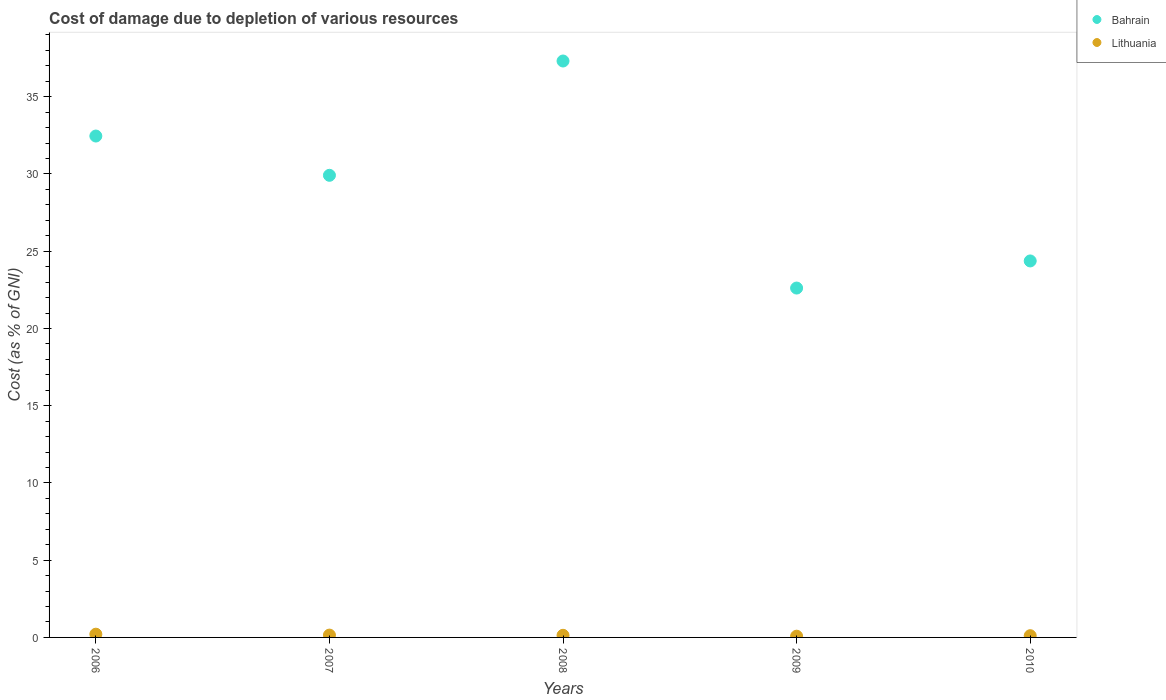How many different coloured dotlines are there?
Provide a short and direct response. 2. Is the number of dotlines equal to the number of legend labels?
Keep it short and to the point. Yes. What is the cost of damage caused due to the depletion of various resources in Lithuania in 2009?
Give a very brief answer. 0.08. Across all years, what is the maximum cost of damage caused due to the depletion of various resources in Bahrain?
Offer a very short reply. 37.31. Across all years, what is the minimum cost of damage caused due to the depletion of various resources in Bahrain?
Offer a very short reply. 22.62. What is the total cost of damage caused due to the depletion of various resources in Lithuania in the graph?
Keep it short and to the point. 0.69. What is the difference between the cost of damage caused due to the depletion of various resources in Bahrain in 2006 and that in 2007?
Make the answer very short. 2.54. What is the difference between the cost of damage caused due to the depletion of various resources in Bahrain in 2008 and the cost of damage caused due to the depletion of various resources in Lithuania in 2009?
Ensure brevity in your answer.  37.23. What is the average cost of damage caused due to the depletion of various resources in Bahrain per year?
Offer a very short reply. 29.33. In the year 2008, what is the difference between the cost of damage caused due to the depletion of various resources in Lithuania and cost of damage caused due to the depletion of various resources in Bahrain?
Your answer should be very brief. -37.18. In how many years, is the cost of damage caused due to the depletion of various resources in Lithuania greater than 28 %?
Your answer should be compact. 0. What is the ratio of the cost of damage caused due to the depletion of various resources in Lithuania in 2006 to that in 2007?
Your response must be concise. 1.39. What is the difference between the highest and the second highest cost of damage caused due to the depletion of various resources in Lithuania?
Offer a very short reply. 0.06. What is the difference between the highest and the lowest cost of damage caused due to the depletion of various resources in Bahrain?
Give a very brief answer. 14.7. Does the cost of damage caused due to the depletion of various resources in Bahrain monotonically increase over the years?
Offer a very short reply. No. Is the cost of damage caused due to the depletion of various resources in Lithuania strictly greater than the cost of damage caused due to the depletion of various resources in Bahrain over the years?
Ensure brevity in your answer.  No. Is the cost of damage caused due to the depletion of various resources in Lithuania strictly less than the cost of damage caused due to the depletion of various resources in Bahrain over the years?
Offer a very short reply. Yes. How many dotlines are there?
Provide a short and direct response. 2. Are the values on the major ticks of Y-axis written in scientific E-notation?
Offer a very short reply. No. Does the graph contain any zero values?
Ensure brevity in your answer.  No. Where does the legend appear in the graph?
Provide a short and direct response. Top right. How many legend labels are there?
Provide a succinct answer. 2. What is the title of the graph?
Your answer should be very brief. Cost of damage due to depletion of various resources. Does "Madagascar" appear as one of the legend labels in the graph?
Make the answer very short. No. What is the label or title of the Y-axis?
Your answer should be compact. Cost (as % of GNI). What is the Cost (as % of GNI) of Bahrain in 2006?
Keep it short and to the point. 32.46. What is the Cost (as % of GNI) of Lithuania in 2006?
Offer a very short reply. 0.21. What is the Cost (as % of GNI) in Bahrain in 2007?
Give a very brief answer. 29.91. What is the Cost (as % of GNI) of Lithuania in 2007?
Give a very brief answer. 0.15. What is the Cost (as % of GNI) of Bahrain in 2008?
Provide a short and direct response. 37.31. What is the Cost (as % of GNI) in Lithuania in 2008?
Make the answer very short. 0.14. What is the Cost (as % of GNI) of Bahrain in 2009?
Offer a terse response. 22.62. What is the Cost (as % of GNI) in Lithuania in 2009?
Ensure brevity in your answer.  0.08. What is the Cost (as % of GNI) in Bahrain in 2010?
Ensure brevity in your answer.  24.37. What is the Cost (as % of GNI) of Lithuania in 2010?
Offer a very short reply. 0.11. Across all years, what is the maximum Cost (as % of GNI) in Bahrain?
Keep it short and to the point. 37.31. Across all years, what is the maximum Cost (as % of GNI) in Lithuania?
Provide a succinct answer. 0.21. Across all years, what is the minimum Cost (as % of GNI) of Bahrain?
Offer a terse response. 22.62. Across all years, what is the minimum Cost (as % of GNI) in Lithuania?
Provide a short and direct response. 0.08. What is the total Cost (as % of GNI) in Bahrain in the graph?
Provide a short and direct response. 146.67. What is the total Cost (as % of GNI) in Lithuania in the graph?
Give a very brief answer. 0.69. What is the difference between the Cost (as % of GNI) in Bahrain in 2006 and that in 2007?
Your answer should be compact. 2.54. What is the difference between the Cost (as % of GNI) in Lithuania in 2006 and that in 2007?
Offer a terse response. 0.06. What is the difference between the Cost (as % of GNI) in Bahrain in 2006 and that in 2008?
Give a very brief answer. -4.86. What is the difference between the Cost (as % of GNI) of Lithuania in 2006 and that in 2008?
Provide a short and direct response. 0.07. What is the difference between the Cost (as % of GNI) in Bahrain in 2006 and that in 2009?
Give a very brief answer. 9.84. What is the difference between the Cost (as % of GNI) of Lithuania in 2006 and that in 2009?
Your answer should be very brief. 0.13. What is the difference between the Cost (as % of GNI) in Bahrain in 2006 and that in 2010?
Your answer should be very brief. 8.09. What is the difference between the Cost (as % of GNI) of Lithuania in 2006 and that in 2010?
Make the answer very short. 0.1. What is the difference between the Cost (as % of GNI) of Bahrain in 2007 and that in 2008?
Provide a short and direct response. -7.4. What is the difference between the Cost (as % of GNI) of Lithuania in 2007 and that in 2008?
Offer a very short reply. 0.01. What is the difference between the Cost (as % of GNI) of Bahrain in 2007 and that in 2009?
Offer a terse response. 7.3. What is the difference between the Cost (as % of GNI) in Lithuania in 2007 and that in 2009?
Make the answer very short. 0.07. What is the difference between the Cost (as % of GNI) of Bahrain in 2007 and that in 2010?
Provide a short and direct response. 5.54. What is the difference between the Cost (as % of GNI) in Lithuania in 2007 and that in 2010?
Make the answer very short. 0.04. What is the difference between the Cost (as % of GNI) in Bahrain in 2008 and that in 2009?
Offer a terse response. 14.7. What is the difference between the Cost (as % of GNI) of Lithuania in 2008 and that in 2009?
Offer a very short reply. 0.06. What is the difference between the Cost (as % of GNI) of Bahrain in 2008 and that in 2010?
Offer a terse response. 12.94. What is the difference between the Cost (as % of GNI) of Lithuania in 2008 and that in 2010?
Provide a succinct answer. 0.03. What is the difference between the Cost (as % of GNI) in Bahrain in 2009 and that in 2010?
Make the answer very short. -1.76. What is the difference between the Cost (as % of GNI) in Lithuania in 2009 and that in 2010?
Keep it short and to the point. -0.03. What is the difference between the Cost (as % of GNI) in Bahrain in 2006 and the Cost (as % of GNI) in Lithuania in 2007?
Offer a terse response. 32.31. What is the difference between the Cost (as % of GNI) of Bahrain in 2006 and the Cost (as % of GNI) of Lithuania in 2008?
Your answer should be compact. 32.32. What is the difference between the Cost (as % of GNI) of Bahrain in 2006 and the Cost (as % of GNI) of Lithuania in 2009?
Your answer should be compact. 32.38. What is the difference between the Cost (as % of GNI) in Bahrain in 2006 and the Cost (as % of GNI) in Lithuania in 2010?
Make the answer very short. 32.35. What is the difference between the Cost (as % of GNI) in Bahrain in 2007 and the Cost (as % of GNI) in Lithuania in 2008?
Offer a very short reply. 29.78. What is the difference between the Cost (as % of GNI) of Bahrain in 2007 and the Cost (as % of GNI) of Lithuania in 2009?
Offer a very short reply. 29.84. What is the difference between the Cost (as % of GNI) in Bahrain in 2007 and the Cost (as % of GNI) in Lithuania in 2010?
Your response must be concise. 29.8. What is the difference between the Cost (as % of GNI) of Bahrain in 2008 and the Cost (as % of GNI) of Lithuania in 2009?
Make the answer very short. 37.23. What is the difference between the Cost (as % of GNI) in Bahrain in 2008 and the Cost (as % of GNI) in Lithuania in 2010?
Provide a succinct answer. 37.2. What is the difference between the Cost (as % of GNI) of Bahrain in 2009 and the Cost (as % of GNI) of Lithuania in 2010?
Your answer should be very brief. 22.5. What is the average Cost (as % of GNI) of Bahrain per year?
Keep it short and to the point. 29.33. What is the average Cost (as % of GNI) of Lithuania per year?
Your answer should be compact. 0.14. In the year 2006, what is the difference between the Cost (as % of GNI) in Bahrain and Cost (as % of GNI) in Lithuania?
Offer a very short reply. 32.25. In the year 2007, what is the difference between the Cost (as % of GNI) in Bahrain and Cost (as % of GNI) in Lithuania?
Your answer should be very brief. 29.76. In the year 2008, what is the difference between the Cost (as % of GNI) of Bahrain and Cost (as % of GNI) of Lithuania?
Offer a terse response. 37.18. In the year 2009, what is the difference between the Cost (as % of GNI) of Bahrain and Cost (as % of GNI) of Lithuania?
Provide a short and direct response. 22.54. In the year 2010, what is the difference between the Cost (as % of GNI) of Bahrain and Cost (as % of GNI) of Lithuania?
Give a very brief answer. 24.26. What is the ratio of the Cost (as % of GNI) in Bahrain in 2006 to that in 2007?
Give a very brief answer. 1.08. What is the ratio of the Cost (as % of GNI) in Lithuania in 2006 to that in 2007?
Your response must be concise. 1.39. What is the ratio of the Cost (as % of GNI) of Bahrain in 2006 to that in 2008?
Your answer should be very brief. 0.87. What is the ratio of the Cost (as % of GNI) of Lithuania in 2006 to that in 2008?
Offer a very short reply. 1.53. What is the ratio of the Cost (as % of GNI) in Bahrain in 2006 to that in 2009?
Keep it short and to the point. 1.44. What is the ratio of the Cost (as % of GNI) in Lithuania in 2006 to that in 2009?
Your answer should be very brief. 2.63. What is the ratio of the Cost (as % of GNI) of Bahrain in 2006 to that in 2010?
Your response must be concise. 1.33. What is the ratio of the Cost (as % of GNI) of Lithuania in 2006 to that in 2010?
Ensure brevity in your answer.  1.87. What is the ratio of the Cost (as % of GNI) of Bahrain in 2007 to that in 2008?
Your answer should be very brief. 0.8. What is the ratio of the Cost (as % of GNI) in Lithuania in 2007 to that in 2008?
Make the answer very short. 1.1. What is the ratio of the Cost (as % of GNI) in Bahrain in 2007 to that in 2009?
Your response must be concise. 1.32. What is the ratio of the Cost (as % of GNI) of Lithuania in 2007 to that in 2009?
Your answer should be compact. 1.89. What is the ratio of the Cost (as % of GNI) in Bahrain in 2007 to that in 2010?
Provide a short and direct response. 1.23. What is the ratio of the Cost (as % of GNI) of Lithuania in 2007 to that in 2010?
Your response must be concise. 1.34. What is the ratio of the Cost (as % of GNI) of Bahrain in 2008 to that in 2009?
Offer a terse response. 1.65. What is the ratio of the Cost (as % of GNI) of Lithuania in 2008 to that in 2009?
Give a very brief answer. 1.72. What is the ratio of the Cost (as % of GNI) of Bahrain in 2008 to that in 2010?
Your answer should be compact. 1.53. What is the ratio of the Cost (as % of GNI) in Lithuania in 2008 to that in 2010?
Your response must be concise. 1.22. What is the ratio of the Cost (as % of GNI) of Bahrain in 2009 to that in 2010?
Provide a short and direct response. 0.93. What is the ratio of the Cost (as % of GNI) in Lithuania in 2009 to that in 2010?
Keep it short and to the point. 0.71. What is the difference between the highest and the second highest Cost (as % of GNI) in Bahrain?
Offer a terse response. 4.86. What is the difference between the highest and the second highest Cost (as % of GNI) of Lithuania?
Your response must be concise. 0.06. What is the difference between the highest and the lowest Cost (as % of GNI) in Bahrain?
Keep it short and to the point. 14.7. What is the difference between the highest and the lowest Cost (as % of GNI) in Lithuania?
Ensure brevity in your answer.  0.13. 